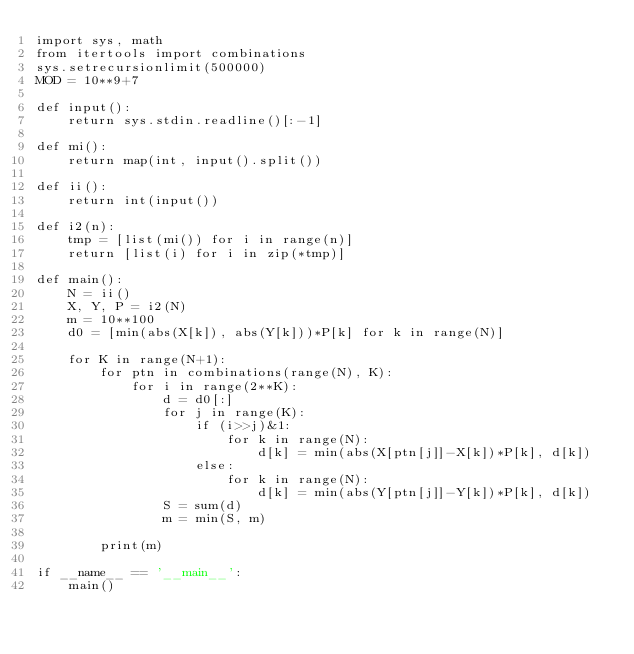<code> <loc_0><loc_0><loc_500><loc_500><_Python_>import sys, math
from itertools import combinations
sys.setrecursionlimit(500000)
MOD = 10**9+7

def input():
    return sys.stdin.readline()[:-1]

def mi():
    return map(int, input().split())

def ii():
    return int(input())

def i2(n):
    tmp = [list(mi()) for i in range(n)]
    return [list(i) for i in zip(*tmp)]

def main():
    N = ii()
    X, Y, P = i2(N)
    m = 10**100
    d0 = [min(abs(X[k]), abs(Y[k]))*P[k] for k in range(N)]

    for K in range(N+1):
        for ptn in combinations(range(N), K):
            for i in range(2**K):
                d = d0[:]
                for j in range(K):
                    if (i>>j)&1:
                        for k in range(N):
                            d[k] = min(abs(X[ptn[j]]-X[k])*P[k], d[k])
                    else:
                        for k in range(N):
                            d[k] = min(abs(Y[ptn[j]]-Y[k])*P[k], d[k])
                S = sum(d)
                m = min(S, m)

        print(m)

if __name__ == '__main__':
    main()</code> 